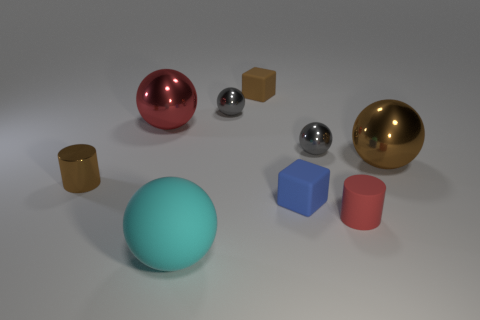What material is the small cube that is to the right of the brown object that is behind the large object that is left of the cyan rubber sphere?
Your answer should be compact. Rubber. What is the red ball made of?
Your answer should be compact. Metal. There is a big metal sphere to the right of the big rubber sphere; is it the same color as the small cylinder that is left of the tiny blue block?
Offer a terse response. Yes. Is the number of metallic cubes greater than the number of red cylinders?
Ensure brevity in your answer.  No. What number of blocks have the same color as the tiny matte cylinder?
Provide a succinct answer. 0. There is another tiny thing that is the same shape as the tiny red matte thing; what color is it?
Your answer should be very brief. Brown. What material is the tiny object that is both in front of the brown cylinder and on the left side of the tiny red rubber thing?
Provide a short and direct response. Rubber. Is the material of the red object that is behind the red matte object the same as the tiny cylinder in front of the small blue rubber cube?
Your answer should be compact. No. How big is the cyan matte ball?
Your response must be concise. Large. What is the size of the brown metallic thing that is the same shape as the small red object?
Your answer should be very brief. Small. 